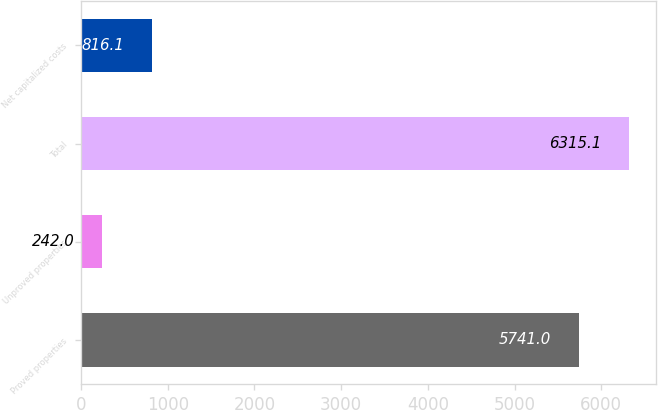Convert chart to OTSL. <chart><loc_0><loc_0><loc_500><loc_500><bar_chart><fcel>Proved properties<fcel>Unproved properties<fcel>Total<fcel>Net capitalized costs<nl><fcel>5741<fcel>242<fcel>6315.1<fcel>816.1<nl></chart> 